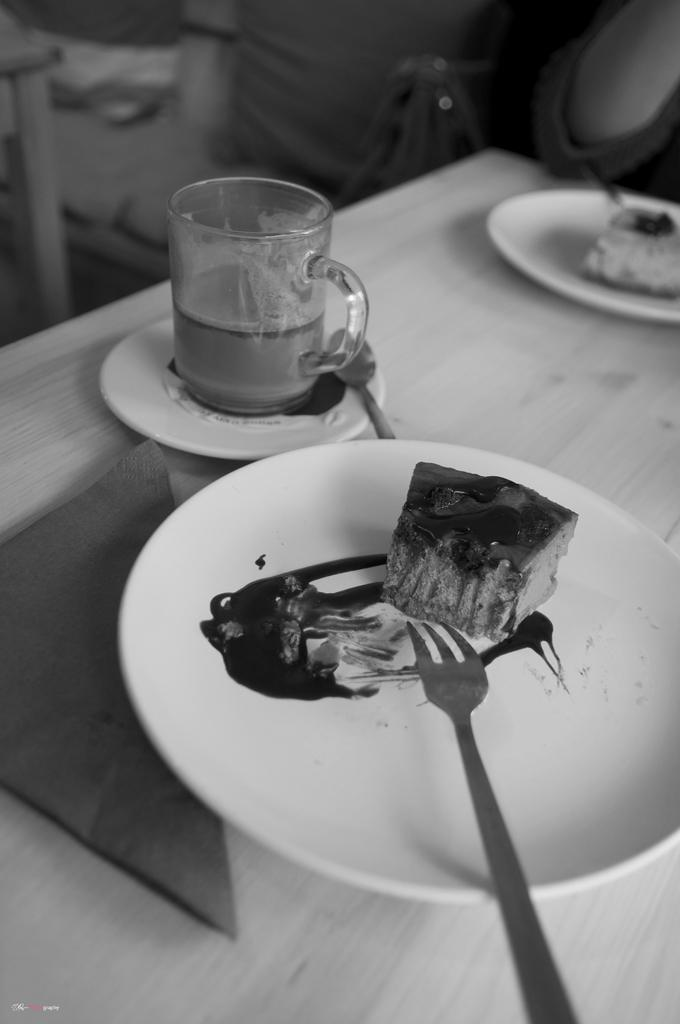What piece of furniture is in the image? There is a table in the image. What is on the table? There are plates with food, a glass cup, a fork, a spoon, and tissue paper on the table. What type of utensils are present on the table? There is a fork and a spoon on the table. What is the background of the image like? The background of the image is blurred. What type of tree is visible in the background of the image? There is no tree visible in the background of the image; the background is blurred. What time of day is the breakfast scene taking place in the image? There is no specific mention of breakfast or a scene in the image; it only shows a table with various items on it. 